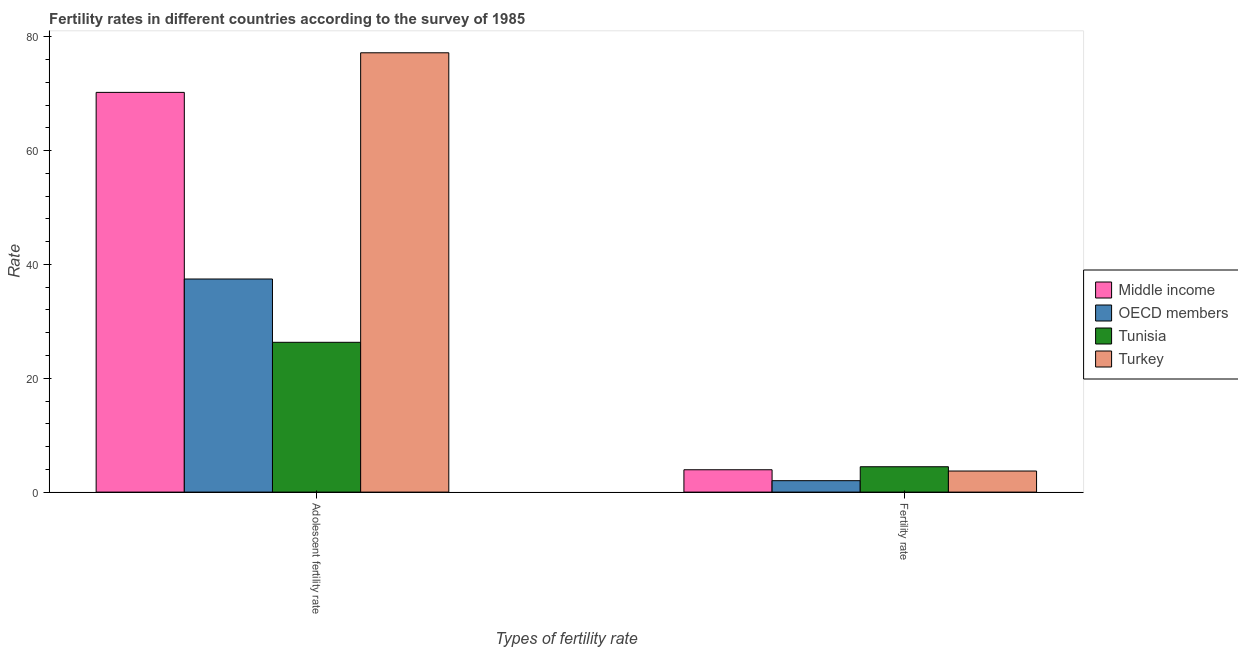Are the number of bars on each tick of the X-axis equal?
Provide a short and direct response. Yes. How many bars are there on the 1st tick from the left?
Offer a very short reply. 4. How many bars are there on the 1st tick from the right?
Provide a short and direct response. 4. What is the label of the 1st group of bars from the left?
Keep it short and to the point. Adolescent fertility rate. What is the fertility rate in Middle income?
Your answer should be compact. 3.93. Across all countries, what is the maximum fertility rate?
Ensure brevity in your answer.  4.45. Across all countries, what is the minimum adolescent fertility rate?
Offer a very short reply. 26.31. In which country was the adolescent fertility rate maximum?
Ensure brevity in your answer.  Turkey. In which country was the fertility rate minimum?
Provide a succinct answer. OECD members. What is the total adolescent fertility rate in the graph?
Make the answer very short. 211.14. What is the difference between the adolescent fertility rate in Turkey and that in Tunisia?
Keep it short and to the point. 50.86. What is the difference between the adolescent fertility rate in Middle income and the fertility rate in OECD members?
Offer a terse response. 68.21. What is the average fertility rate per country?
Ensure brevity in your answer.  3.52. What is the difference between the fertility rate and adolescent fertility rate in Turkey?
Offer a terse response. -73.47. In how many countries, is the fertility rate greater than 32 ?
Keep it short and to the point. 0. What is the ratio of the fertility rate in OECD members to that in Middle income?
Your answer should be very brief. 0.51. Is the fertility rate in Middle income less than that in Turkey?
Provide a short and direct response. No. In how many countries, is the adolescent fertility rate greater than the average adolescent fertility rate taken over all countries?
Your answer should be compact. 2. What does the 4th bar from the left in Fertility rate represents?
Ensure brevity in your answer.  Turkey. How many bars are there?
Offer a very short reply. 8. What is the difference between two consecutive major ticks on the Y-axis?
Your answer should be compact. 20. Are the values on the major ticks of Y-axis written in scientific E-notation?
Make the answer very short. No. Where does the legend appear in the graph?
Give a very brief answer. Center right. How are the legend labels stacked?
Give a very brief answer. Vertical. What is the title of the graph?
Make the answer very short. Fertility rates in different countries according to the survey of 1985. What is the label or title of the X-axis?
Make the answer very short. Types of fertility rate. What is the label or title of the Y-axis?
Offer a terse response. Rate. What is the Rate in Middle income in Adolescent fertility rate?
Your response must be concise. 70.22. What is the Rate in OECD members in Adolescent fertility rate?
Keep it short and to the point. 37.43. What is the Rate of Tunisia in Adolescent fertility rate?
Ensure brevity in your answer.  26.31. What is the Rate of Turkey in Adolescent fertility rate?
Your answer should be very brief. 77.17. What is the Rate in Middle income in Fertility rate?
Make the answer very short. 3.93. What is the Rate of OECD members in Fertility rate?
Give a very brief answer. 2.01. What is the Rate of Tunisia in Fertility rate?
Offer a terse response. 4.45. What is the Rate of Turkey in Fertility rate?
Your answer should be very brief. 3.7. Across all Types of fertility rate, what is the maximum Rate in Middle income?
Make the answer very short. 70.22. Across all Types of fertility rate, what is the maximum Rate of OECD members?
Offer a terse response. 37.43. Across all Types of fertility rate, what is the maximum Rate of Tunisia?
Your response must be concise. 26.31. Across all Types of fertility rate, what is the maximum Rate in Turkey?
Ensure brevity in your answer.  77.17. Across all Types of fertility rate, what is the minimum Rate of Middle income?
Provide a succinct answer. 3.93. Across all Types of fertility rate, what is the minimum Rate in OECD members?
Provide a short and direct response. 2.01. Across all Types of fertility rate, what is the minimum Rate in Tunisia?
Ensure brevity in your answer.  4.45. Across all Types of fertility rate, what is the minimum Rate of Turkey?
Your answer should be compact. 3.7. What is the total Rate in Middle income in the graph?
Provide a succinct answer. 74.14. What is the total Rate of OECD members in the graph?
Keep it short and to the point. 39.44. What is the total Rate in Tunisia in the graph?
Offer a very short reply. 30.77. What is the total Rate in Turkey in the graph?
Ensure brevity in your answer.  80.88. What is the difference between the Rate of Middle income in Adolescent fertility rate and that in Fertility rate?
Your answer should be very brief. 66.29. What is the difference between the Rate in OECD members in Adolescent fertility rate and that in Fertility rate?
Offer a very short reply. 35.43. What is the difference between the Rate of Tunisia in Adolescent fertility rate and that in Fertility rate?
Your answer should be very brief. 21.86. What is the difference between the Rate in Turkey in Adolescent fertility rate and that in Fertility rate?
Offer a terse response. 73.47. What is the difference between the Rate of Middle income in Adolescent fertility rate and the Rate of OECD members in Fertility rate?
Give a very brief answer. 68.21. What is the difference between the Rate in Middle income in Adolescent fertility rate and the Rate in Tunisia in Fertility rate?
Your response must be concise. 65.76. What is the difference between the Rate in Middle income in Adolescent fertility rate and the Rate in Turkey in Fertility rate?
Keep it short and to the point. 66.51. What is the difference between the Rate of OECD members in Adolescent fertility rate and the Rate of Tunisia in Fertility rate?
Provide a succinct answer. 32.98. What is the difference between the Rate of OECD members in Adolescent fertility rate and the Rate of Turkey in Fertility rate?
Provide a short and direct response. 33.73. What is the difference between the Rate of Tunisia in Adolescent fertility rate and the Rate of Turkey in Fertility rate?
Make the answer very short. 22.61. What is the average Rate in Middle income per Types of fertility rate?
Your answer should be very brief. 37.07. What is the average Rate in OECD members per Types of fertility rate?
Provide a succinct answer. 19.72. What is the average Rate in Tunisia per Types of fertility rate?
Ensure brevity in your answer.  15.38. What is the average Rate of Turkey per Types of fertility rate?
Your response must be concise. 40.44. What is the difference between the Rate in Middle income and Rate in OECD members in Adolescent fertility rate?
Offer a terse response. 32.78. What is the difference between the Rate of Middle income and Rate of Tunisia in Adolescent fertility rate?
Your response must be concise. 43.9. What is the difference between the Rate of Middle income and Rate of Turkey in Adolescent fertility rate?
Provide a short and direct response. -6.96. What is the difference between the Rate of OECD members and Rate of Tunisia in Adolescent fertility rate?
Your answer should be compact. 11.12. What is the difference between the Rate in OECD members and Rate in Turkey in Adolescent fertility rate?
Give a very brief answer. -39.74. What is the difference between the Rate in Tunisia and Rate in Turkey in Adolescent fertility rate?
Provide a succinct answer. -50.86. What is the difference between the Rate of Middle income and Rate of OECD members in Fertility rate?
Offer a very short reply. 1.92. What is the difference between the Rate of Middle income and Rate of Tunisia in Fertility rate?
Keep it short and to the point. -0.53. What is the difference between the Rate of Middle income and Rate of Turkey in Fertility rate?
Keep it short and to the point. 0.22. What is the difference between the Rate in OECD members and Rate in Tunisia in Fertility rate?
Provide a short and direct response. -2.45. What is the difference between the Rate in OECD members and Rate in Turkey in Fertility rate?
Your answer should be very brief. -1.7. What is the difference between the Rate of Tunisia and Rate of Turkey in Fertility rate?
Give a very brief answer. 0.75. What is the ratio of the Rate of Middle income in Adolescent fertility rate to that in Fertility rate?
Offer a terse response. 17.89. What is the ratio of the Rate of OECD members in Adolescent fertility rate to that in Fertility rate?
Give a very brief answer. 18.65. What is the ratio of the Rate of Tunisia in Adolescent fertility rate to that in Fertility rate?
Give a very brief answer. 5.91. What is the ratio of the Rate of Turkey in Adolescent fertility rate to that in Fertility rate?
Provide a short and direct response. 20.84. What is the difference between the highest and the second highest Rate of Middle income?
Offer a terse response. 66.29. What is the difference between the highest and the second highest Rate of OECD members?
Keep it short and to the point. 35.43. What is the difference between the highest and the second highest Rate in Tunisia?
Your answer should be compact. 21.86. What is the difference between the highest and the second highest Rate in Turkey?
Offer a terse response. 73.47. What is the difference between the highest and the lowest Rate in Middle income?
Offer a terse response. 66.29. What is the difference between the highest and the lowest Rate in OECD members?
Ensure brevity in your answer.  35.43. What is the difference between the highest and the lowest Rate of Tunisia?
Provide a short and direct response. 21.86. What is the difference between the highest and the lowest Rate of Turkey?
Your response must be concise. 73.47. 